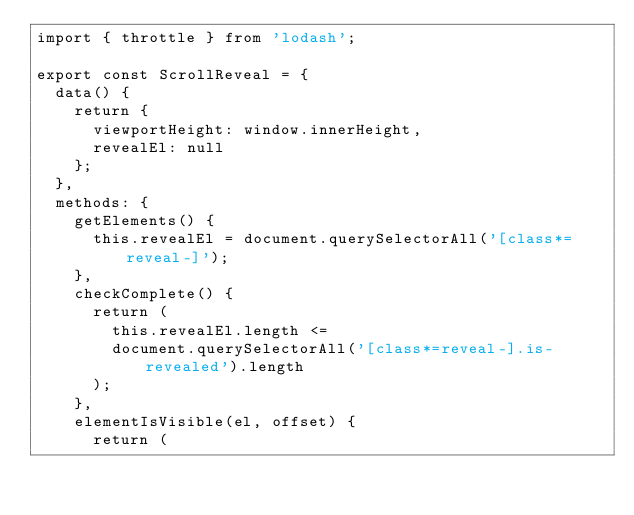Convert code to text. <code><loc_0><loc_0><loc_500><loc_500><_JavaScript_>import { throttle } from 'lodash';

export const ScrollReveal = {
  data() {
    return {
      viewportHeight: window.innerHeight,
      revealEl: null
    };
  },
  methods: {
    getElements() {
      this.revealEl = document.querySelectorAll('[class*=reveal-]');
    },
    checkComplete() {
      return (
        this.revealEl.length <=
        document.querySelectorAll('[class*=reveal-].is-revealed').length
      );
    },
    elementIsVisible(el, offset) {
      return (</code> 